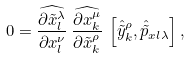Convert formula to latex. <formula><loc_0><loc_0><loc_500><loc_500>0 = \widehat { \frac { \partial \tilde { x } ^ { \lambda } _ { l } } { \partial x ^ { \nu } _ { l } } } \, \widehat { \frac { \partial x ^ { \mu } _ { k } } { \partial \tilde { x } ^ { \rho } _ { k } } } \, \left [ \hat { \tilde { y } } ^ { \rho } _ { k } , \hat { \tilde { p } } _ { x l \lambda } \right ] ,</formula> 